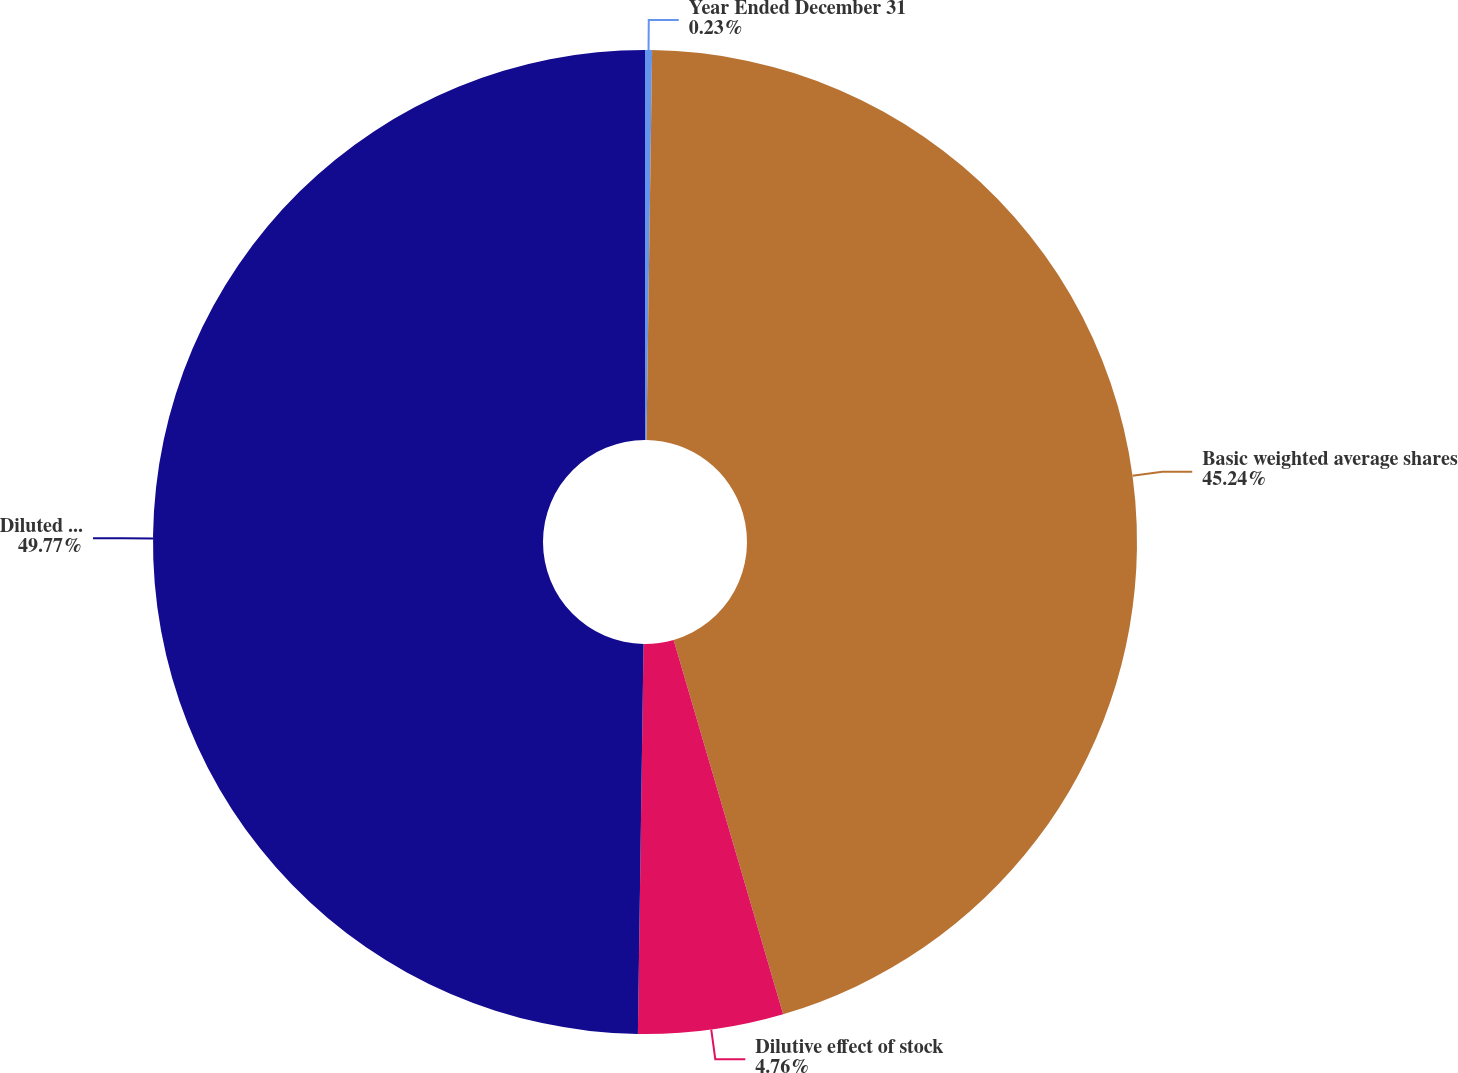Convert chart. <chart><loc_0><loc_0><loc_500><loc_500><pie_chart><fcel>Year Ended December 31<fcel>Basic weighted average shares<fcel>Dilutive effect of stock<fcel>Diluted weighted average<nl><fcel>0.23%<fcel>45.24%<fcel>4.76%<fcel>49.77%<nl></chart> 